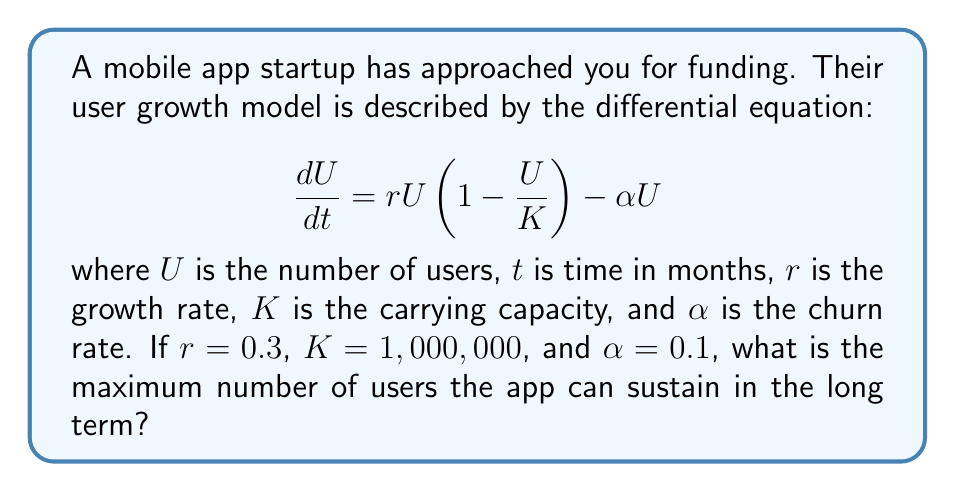Show me your answer to this math problem. To find the maximum number of users the app can sustain in the long term, we need to find the equilibrium point of the differential equation. This occurs when $\frac{dU}{dt} = 0$.

Step 1: Set the equation equal to zero:
$$0 = rU(1-\frac{U}{K}) - \alpha U$$

Step 2: Factor out $U$:
$$0 = U(r(1-\frac{U}{K}) - \alpha)$$

Step 3: Solve for $U$. Either $U=0$ (trivial solution) or:
$$r(1-\frac{U}{K}) - \alpha = 0$$

Step 4: Solve for $U$:
$$r - \frac{rU}{K} = \alpha$$
$$r - \alpha = \frac{rU}{K}$$
$$U = \frac{K(r-\alpha)}{r}$$

Step 5: Substitute the given values:
$$U = \frac{1,000,000(0.3-0.1)}{0.3}$$
$$U = \frac{1,000,000(0.2)}{0.3}$$
$$U = 666,666.67$$

Therefore, the maximum number of users the app can sustain in the long term is approximately 666,667 users.
Answer: 666,667 users 